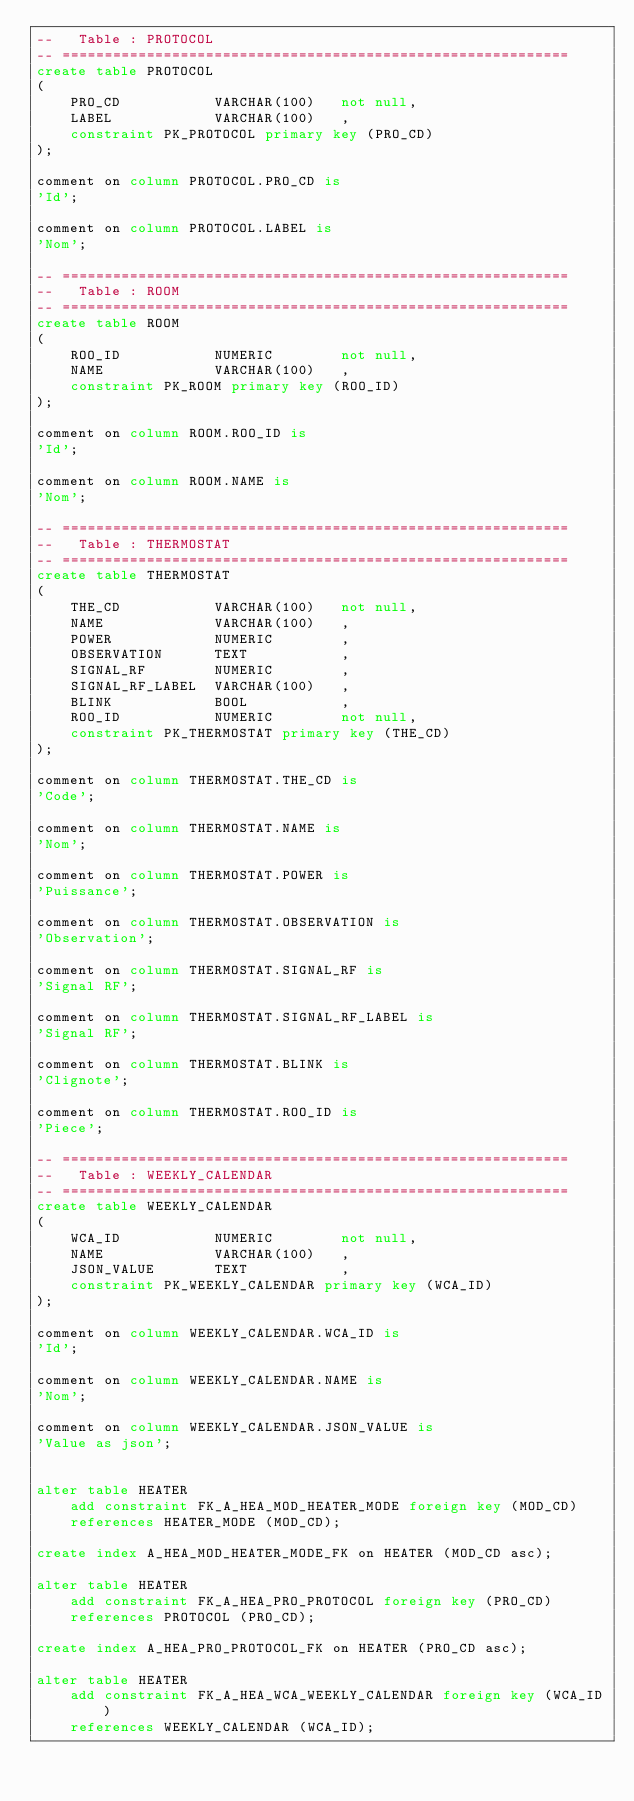<code> <loc_0><loc_0><loc_500><loc_500><_SQL_>--   Table : PROTOCOL                                        
-- ============================================================
create table PROTOCOL
(
    PRO_CD      	 VARCHAR(100)	not null,
    LABEL       	 VARCHAR(100)	,
    constraint PK_PROTOCOL primary key (PRO_CD)
);

comment on column PROTOCOL.PRO_CD is
'Id';

comment on column PROTOCOL.LABEL is
'Nom';

-- ============================================================
--   Table : ROOM                                        
-- ============================================================
create table ROOM
(
    ROO_ID      	 NUMERIC     	not null,
    NAME        	 VARCHAR(100)	,
    constraint PK_ROOM primary key (ROO_ID)
);

comment on column ROOM.ROO_ID is
'Id';

comment on column ROOM.NAME is
'Nom';

-- ============================================================
--   Table : THERMOSTAT                                        
-- ============================================================
create table THERMOSTAT
(
    THE_CD      	 VARCHAR(100)	not null,
    NAME        	 VARCHAR(100)	,
    POWER       	 NUMERIC     	,
    OBSERVATION 	 TEXT        	,
    SIGNAL_RF   	 NUMERIC     	,
    SIGNAL_RF_LABEL	 VARCHAR(100)	,
    BLINK       	 BOOL        	,
    ROO_ID      	 NUMERIC     	not null,
    constraint PK_THERMOSTAT primary key (THE_CD)
);

comment on column THERMOSTAT.THE_CD is
'Code';

comment on column THERMOSTAT.NAME is
'Nom';

comment on column THERMOSTAT.POWER is
'Puissance';

comment on column THERMOSTAT.OBSERVATION is
'Observation';

comment on column THERMOSTAT.SIGNAL_RF is
'Signal RF';

comment on column THERMOSTAT.SIGNAL_RF_LABEL is
'Signal RF';

comment on column THERMOSTAT.BLINK is
'Clignote';

comment on column THERMOSTAT.ROO_ID is
'Piece';

-- ============================================================
--   Table : WEEKLY_CALENDAR                                        
-- ============================================================
create table WEEKLY_CALENDAR
(
    WCA_ID      	 NUMERIC     	not null,
    NAME        	 VARCHAR(100)	,
    JSON_VALUE  	 TEXT        	,
    constraint PK_WEEKLY_CALENDAR primary key (WCA_ID)
);

comment on column WEEKLY_CALENDAR.WCA_ID is
'Id';

comment on column WEEKLY_CALENDAR.NAME is
'Nom';

comment on column WEEKLY_CALENDAR.JSON_VALUE is
'Value as json';


alter table HEATER
	add constraint FK_A_HEA_MOD_HEATER_MODE foreign key (MOD_CD)
	references HEATER_MODE (MOD_CD);

create index A_HEA_MOD_HEATER_MODE_FK on HEATER (MOD_CD asc);

alter table HEATER
	add constraint FK_A_HEA_PRO_PROTOCOL foreign key (PRO_CD)
	references PROTOCOL (PRO_CD);

create index A_HEA_PRO_PROTOCOL_FK on HEATER (PRO_CD asc);

alter table HEATER
	add constraint FK_A_HEA_WCA_WEEKLY_CALENDAR foreign key (WCA_ID)
	references WEEKLY_CALENDAR (WCA_ID);
</code> 